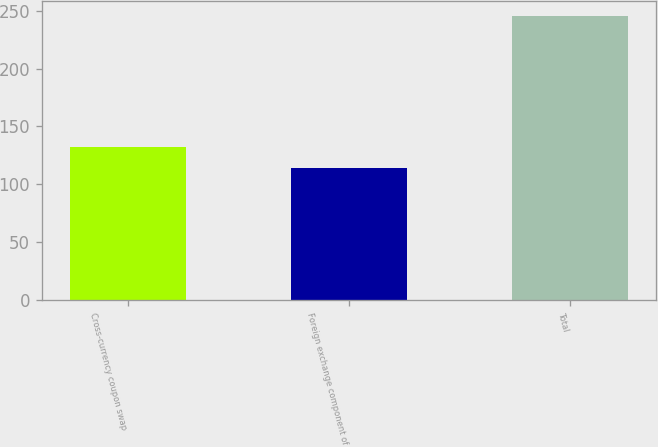Convert chart. <chart><loc_0><loc_0><loc_500><loc_500><bar_chart><fcel>Cross-currency coupon swap<fcel>Foreign exchange component of<fcel>Total<nl><fcel>132<fcel>114<fcel>246<nl></chart> 